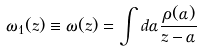Convert formula to latex. <formula><loc_0><loc_0><loc_500><loc_500>\omega _ { 1 } ( z ) \equiv \omega ( z ) = \int d \alpha \frac { \rho ( \alpha ) } { z - \alpha }</formula> 